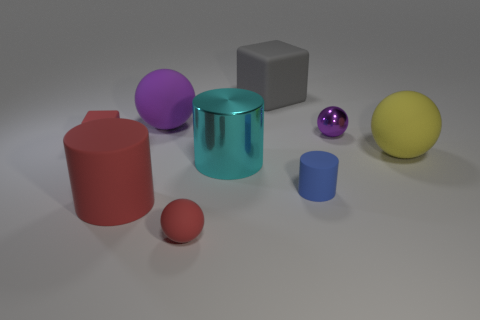There is a matte thing that is the same color as the small shiny object; what is its shape?
Make the answer very short. Sphere. What is the color of the shiny thing on the left side of the small thing behind the tiny red thing that is behind the small blue rubber cylinder?
Give a very brief answer. Cyan. There is a matte cylinder that is the same size as the red sphere; what color is it?
Make the answer very short. Blue. There is a large rubber cube; does it have the same color as the small rubber thing that is behind the blue cylinder?
Ensure brevity in your answer.  No. What is the tiny sphere in front of the metal object that is in front of the yellow thing made of?
Keep it short and to the point. Rubber. What number of spheres are right of the small blue object and in front of the metal ball?
Provide a succinct answer. 1. What number of other objects are the same size as the purple rubber ball?
Ensure brevity in your answer.  4. There is a tiny red thing that is in front of the red cube; is it the same shape as the small metallic object on the right side of the red cube?
Offer a very short reply. Yes. There is a gray matte thing; are there any rubber balls in front of it?
Your answer should be very brief. Yes. What color is the other tiny rubber thing that is the same shape as the cyan object?
Offer a terse response. Blue. 